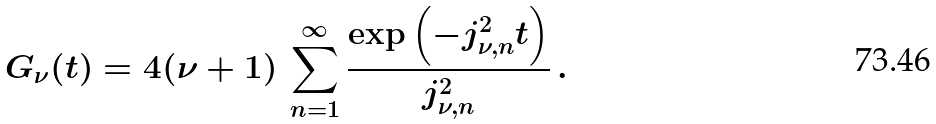Convert formula to latex. <formula><loc_0><loc_0><loc_500><loc_500>G _ { \nu } ( t ) = 4 ( \nu + 1 ) \, \sum _ { n = 1 } ^ { \infty } \frac { \exp \left ( - j _ { \nu , n } ^ { 2 } t \right ) } { j _ { \nu , n } ^ { 2 } } \, .</formula> 